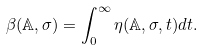<formula> <loc_0><loc_0><loc_500><loc_500>\beta ( \mathbb { A } , \sigma ) = \int ^ { \infty } _ { 0 } \eta ( \mathbb { A } , \sigma , t ) d t .</formula> 